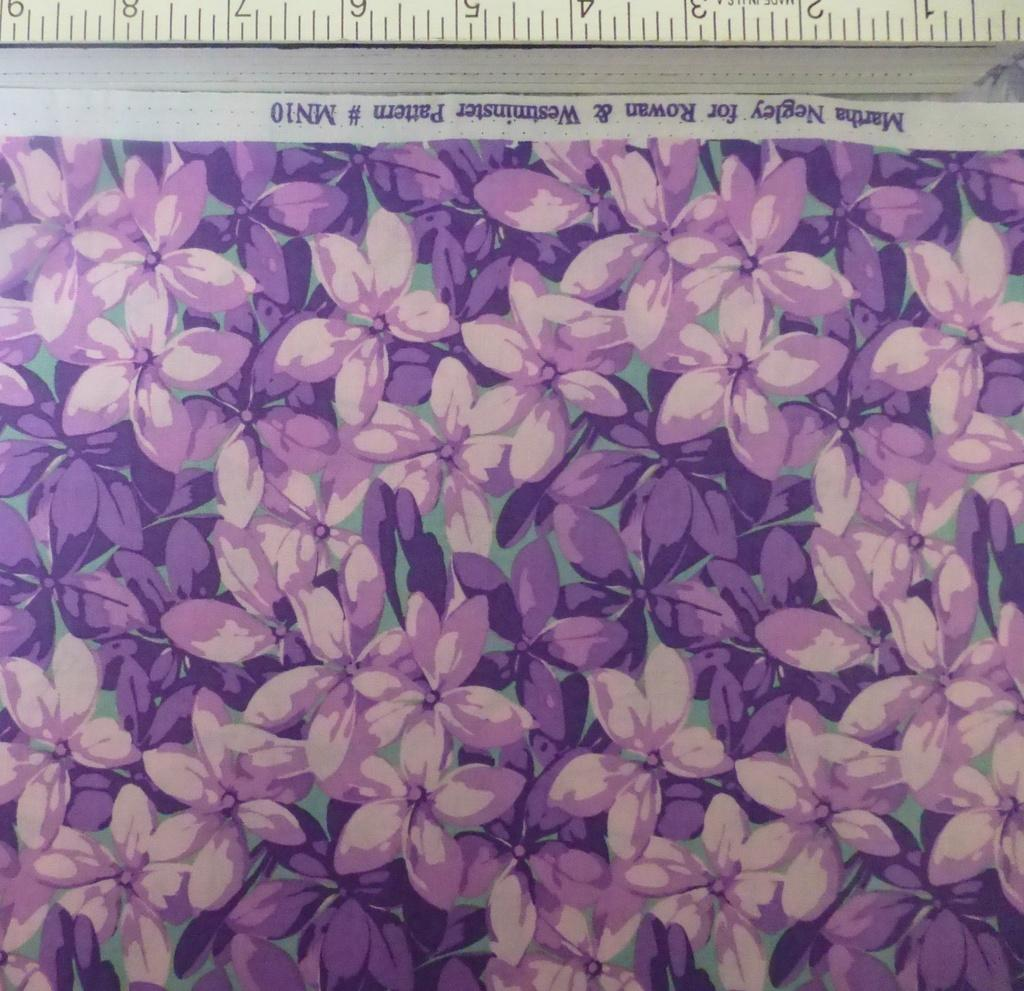What type of measuring object is in the image? There is a measuring object in the image, but the specific type cannot be determined from the provided facts. What is depicted in the painting in the image? There is a painting of flowers in the image. What can be seen in the form of written words in the image? There is some text visible in the image. Can you see a monkey playing with yarn in the image? There is no monkey or yarn present in the image. Is there a fire burning in the image? There is no fire present in the image. 